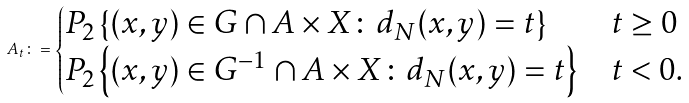<formula> <loc_0><loc_0><loc_500><loc_500>A _ { t } \colon = \begin{cases} P _ { 2 } \left \{ ( x , y ) \in G \cap A \times X \colon d _ { N } ( x , y ) = t \right \} & t \geq 0 \\ P _ { 2 } \left \{ ( x , y ) \in G ^ { - 1 } \cap A \times X \colon d _ { N } ( x , y ) = t \right \} & t < 0 . \end{cases}</formula> 